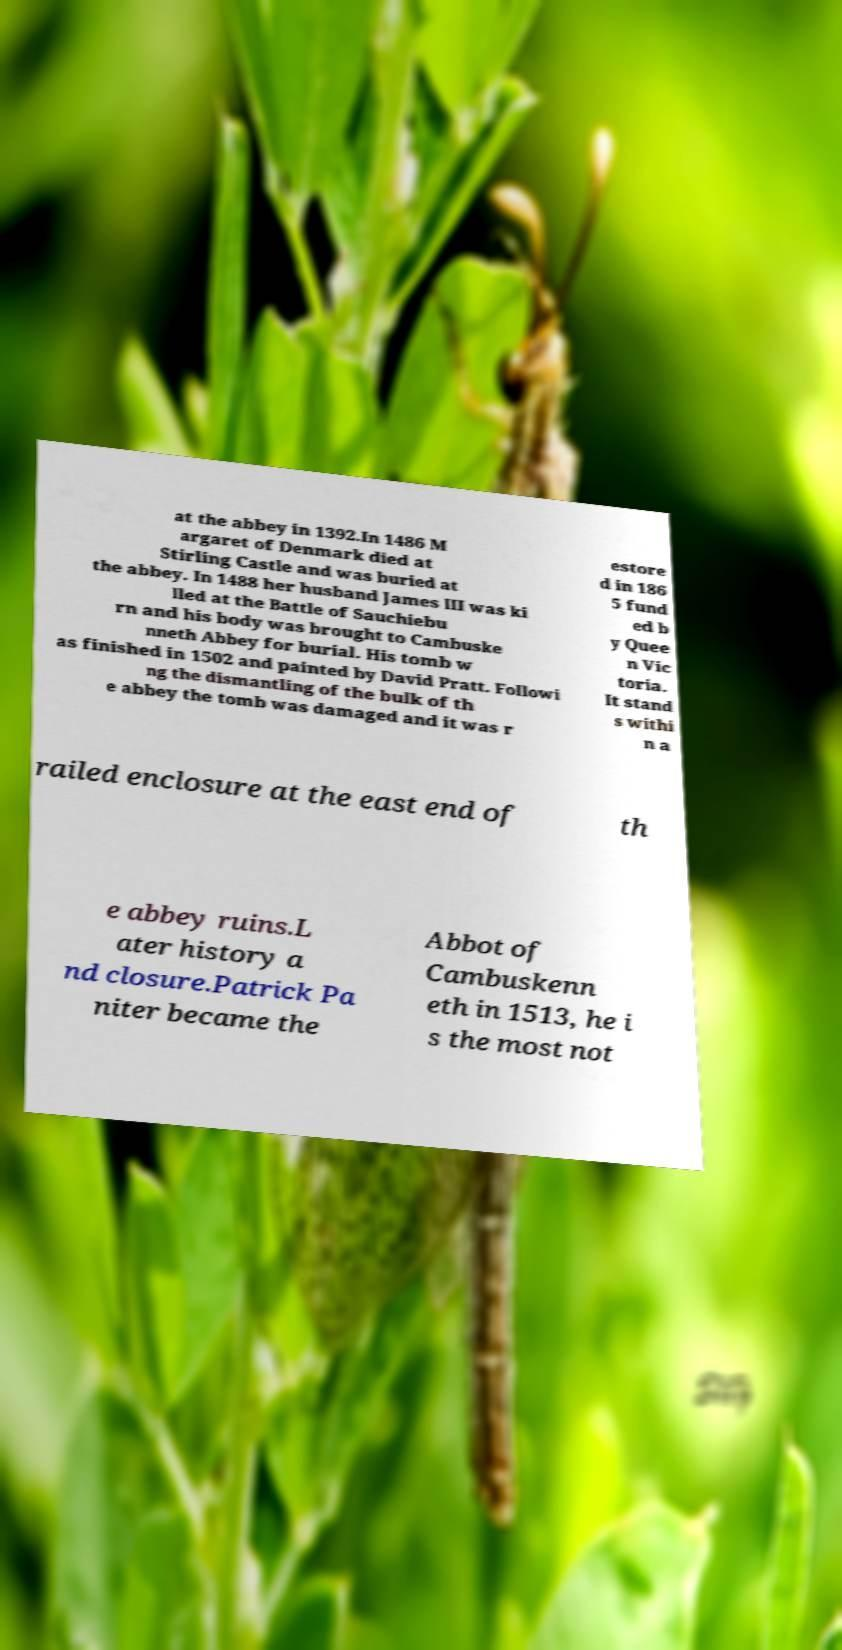Can you accurately transcribe the text from the provided image for me? at the abbey in 1392.In 1486 M argaret of Denmark died at Stirling Castle and was buried at the abbey. In 1488 her husband James III was ki lled at the Battle of Sauchiebu rn and his body was brought to Cambuske nneth Abbey for burial. His tomb w as finished in 1502 and painted by David Pratt. Followi ng the dismantling of the bulk of th e abbey the tomb was damaged and it was r estore d in 186 5 fund ed b y Quee n Vic toria. It stand s withi n a railed enclosure at the east end of th e abbey ruins.L ater history a nd closure.Patrick Pa niter became the Abbot of Cambuskenn eth in 1513, he i s the most not 